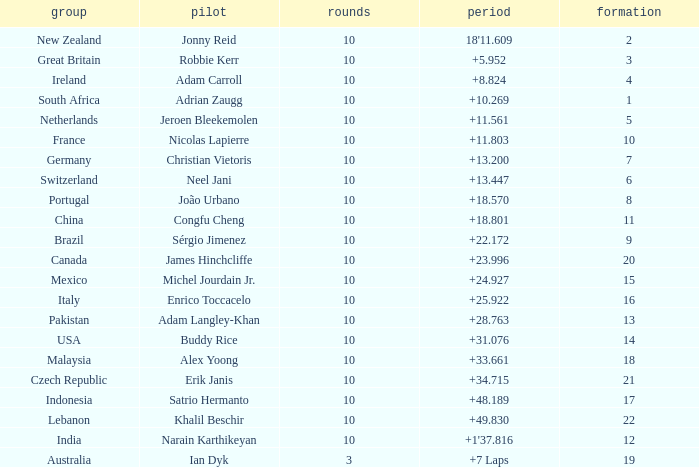What team had 10 Labs and the Driver was Alex Yoong? Malaysia. 